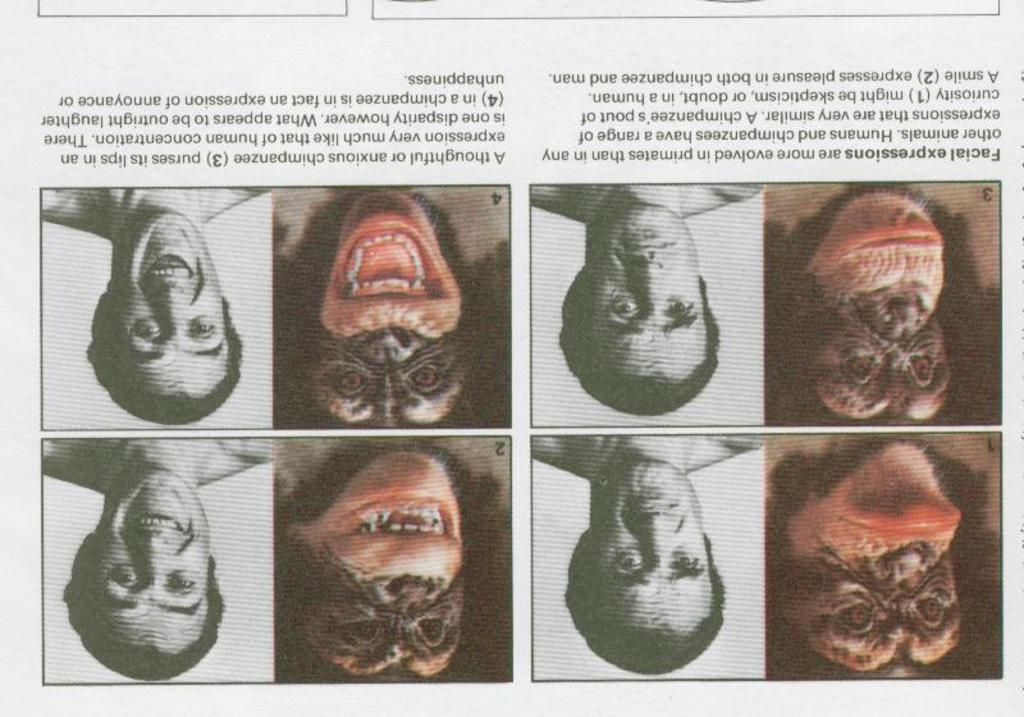What type of image is shown in the collage? The image is a photo collage. Can you identify any subjects in the photos of the collage? Yes, there is a photo of a human and a photo of a chimpanzee in the collage. What type of glove is the chimpanzee wearing in the image? There is no glove visible on the chimpanzee in the image. How many moons can be seen in the background of the photo of the human? There is no moon visible in the background of the photo of the human in the image. 